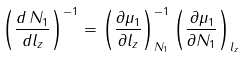<formula> <loc_0><loc_0><loc_500><loc_500>\left ( \frac { d \, N _ { 1 } } { d l _ { z } } \right ) ^ { - 1 } = \left ( \frac { \partial \mu _ { 1 } } { \partial l _ { z } } \right ) _ { N _ { 1 } } ^ { - 1 } \left ( \frac { \partial \mu _ { 1 } } { \partial N _ { 1 } } \right ) _ { l _ { z } }</formula> 